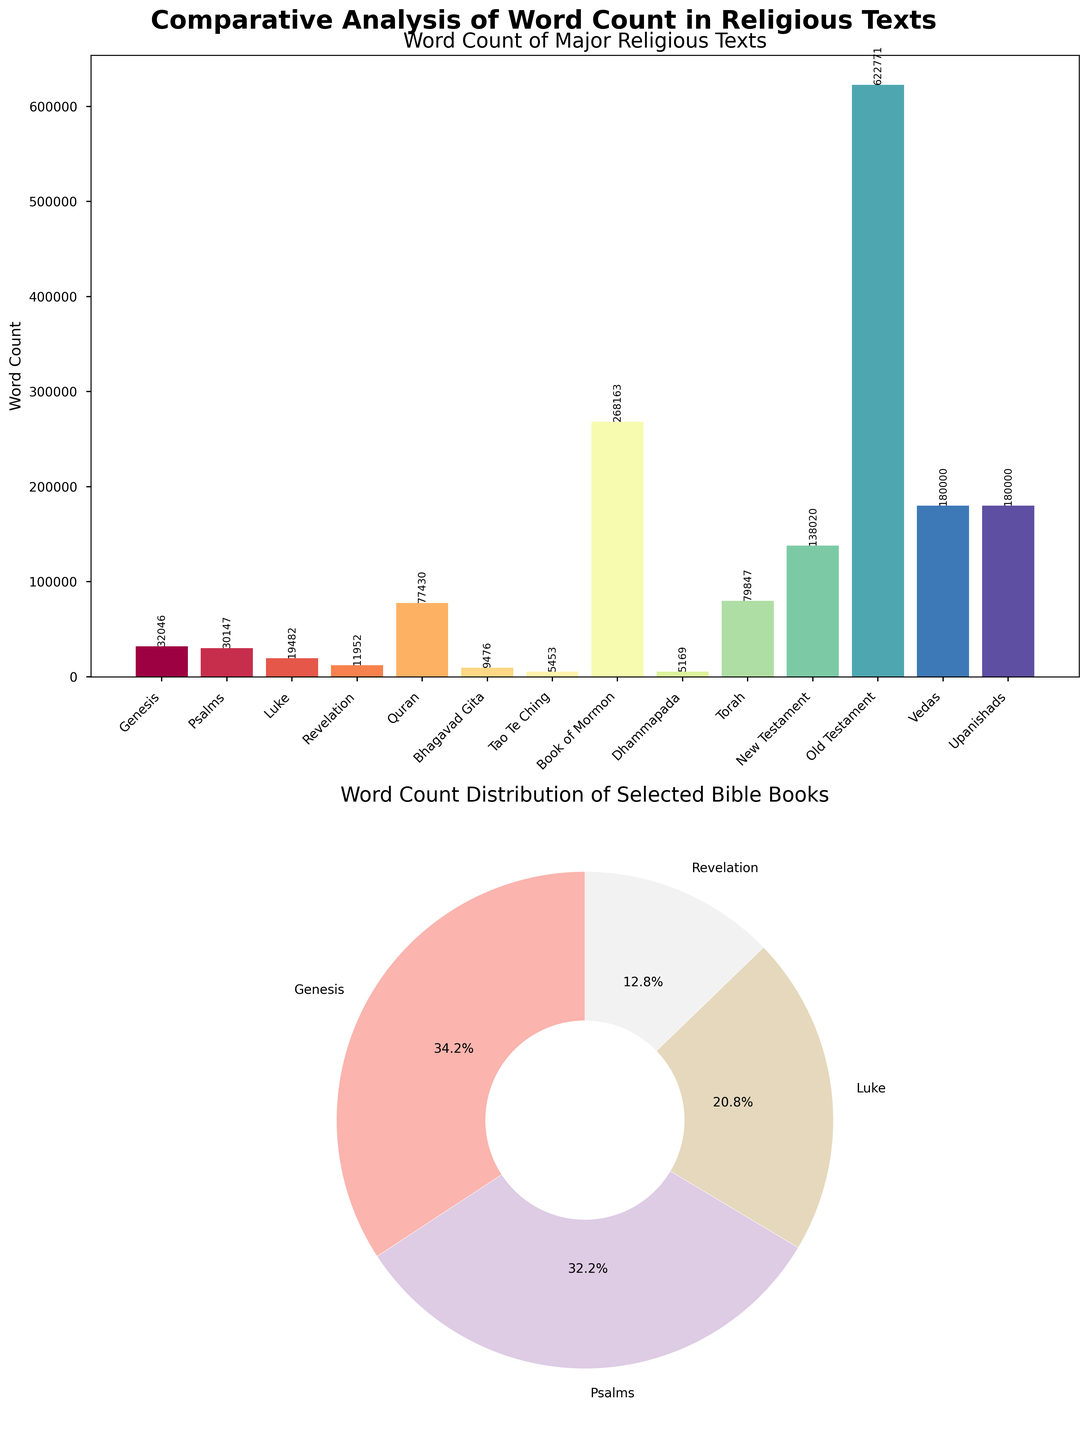Which religious text has the highest word count according to the bar plot? Look at the bar plot and identify the text with the tallest bar. The bar for the "Old Testament" is the tallest.
Answer: Old Testament What is the word count of the Bhagavad Gita? Observe the label on the bar corresponding to the Bhagavad Gita. The label reads 9476.
Answer: 9476 Which two texts together have a word count greater than the Vedas? Check the word counts from the bar plot and find a pair that adds up to more than 180000. The "Book of Mormon" and "New Testament" combined (268163 + 138020) exceed 180000.
Answer: Book of Mormon and New Testament What percentage of the selected Bible books' total word count does Psalms represent? Sum the word counts of Genesis, Psalms, Luke, and Revelation to find the total. Psalms’ percentage is (30147 / (32046 + 30147 + 19482 + 11952)) * 100 = 26.1%.
Answer: 26.1% How many religious texts are compared in the bar plot? Count the number of bars in the bar plot. There are 14 bars.
Answer: 14 Between the Torah and the Quran, which text has a higher word count and by how much? Compare the lengths of the bars for the Torah and the Quran. The Torah (79847) has more words than the Quran (77430). The difference is 79847 - 77430 = 2417.
Answer: Torah by 2417 Which Bible book has the smallest word count among the ones shown in the pie chart? Find the smallest segment in the pie chart. The pie chart shows Revelation with the smallest segment.
Answer: Revelation By how much is the word count of the Book of Mormon higher than that of the New Testament? Find the difference in the heights of the bars for The Book of Mormon and the New Testament. The Book of Mormon (268163) minus the New Testament (138020) equals 130143.
Answer: 130143 What is the total word count of the books of the Bible shown in the pie chart? Sum the word counts of Genesis, Psalms, Luke, and Revelation. Their total is 32046 + 30147 + 19482 + 11952 = 93627.
Answer: 93627 Which religious texts have word counts less than 10,000? Identify the bars for texts with a height corresponding to less than 10,000 words. The texts are Bhagavad Gita (9476), Tao Te Ching (5453), and Dhammapada (5169).
Answer: Bhagavad Gita, Tao Te Ching, and Dhammapada 